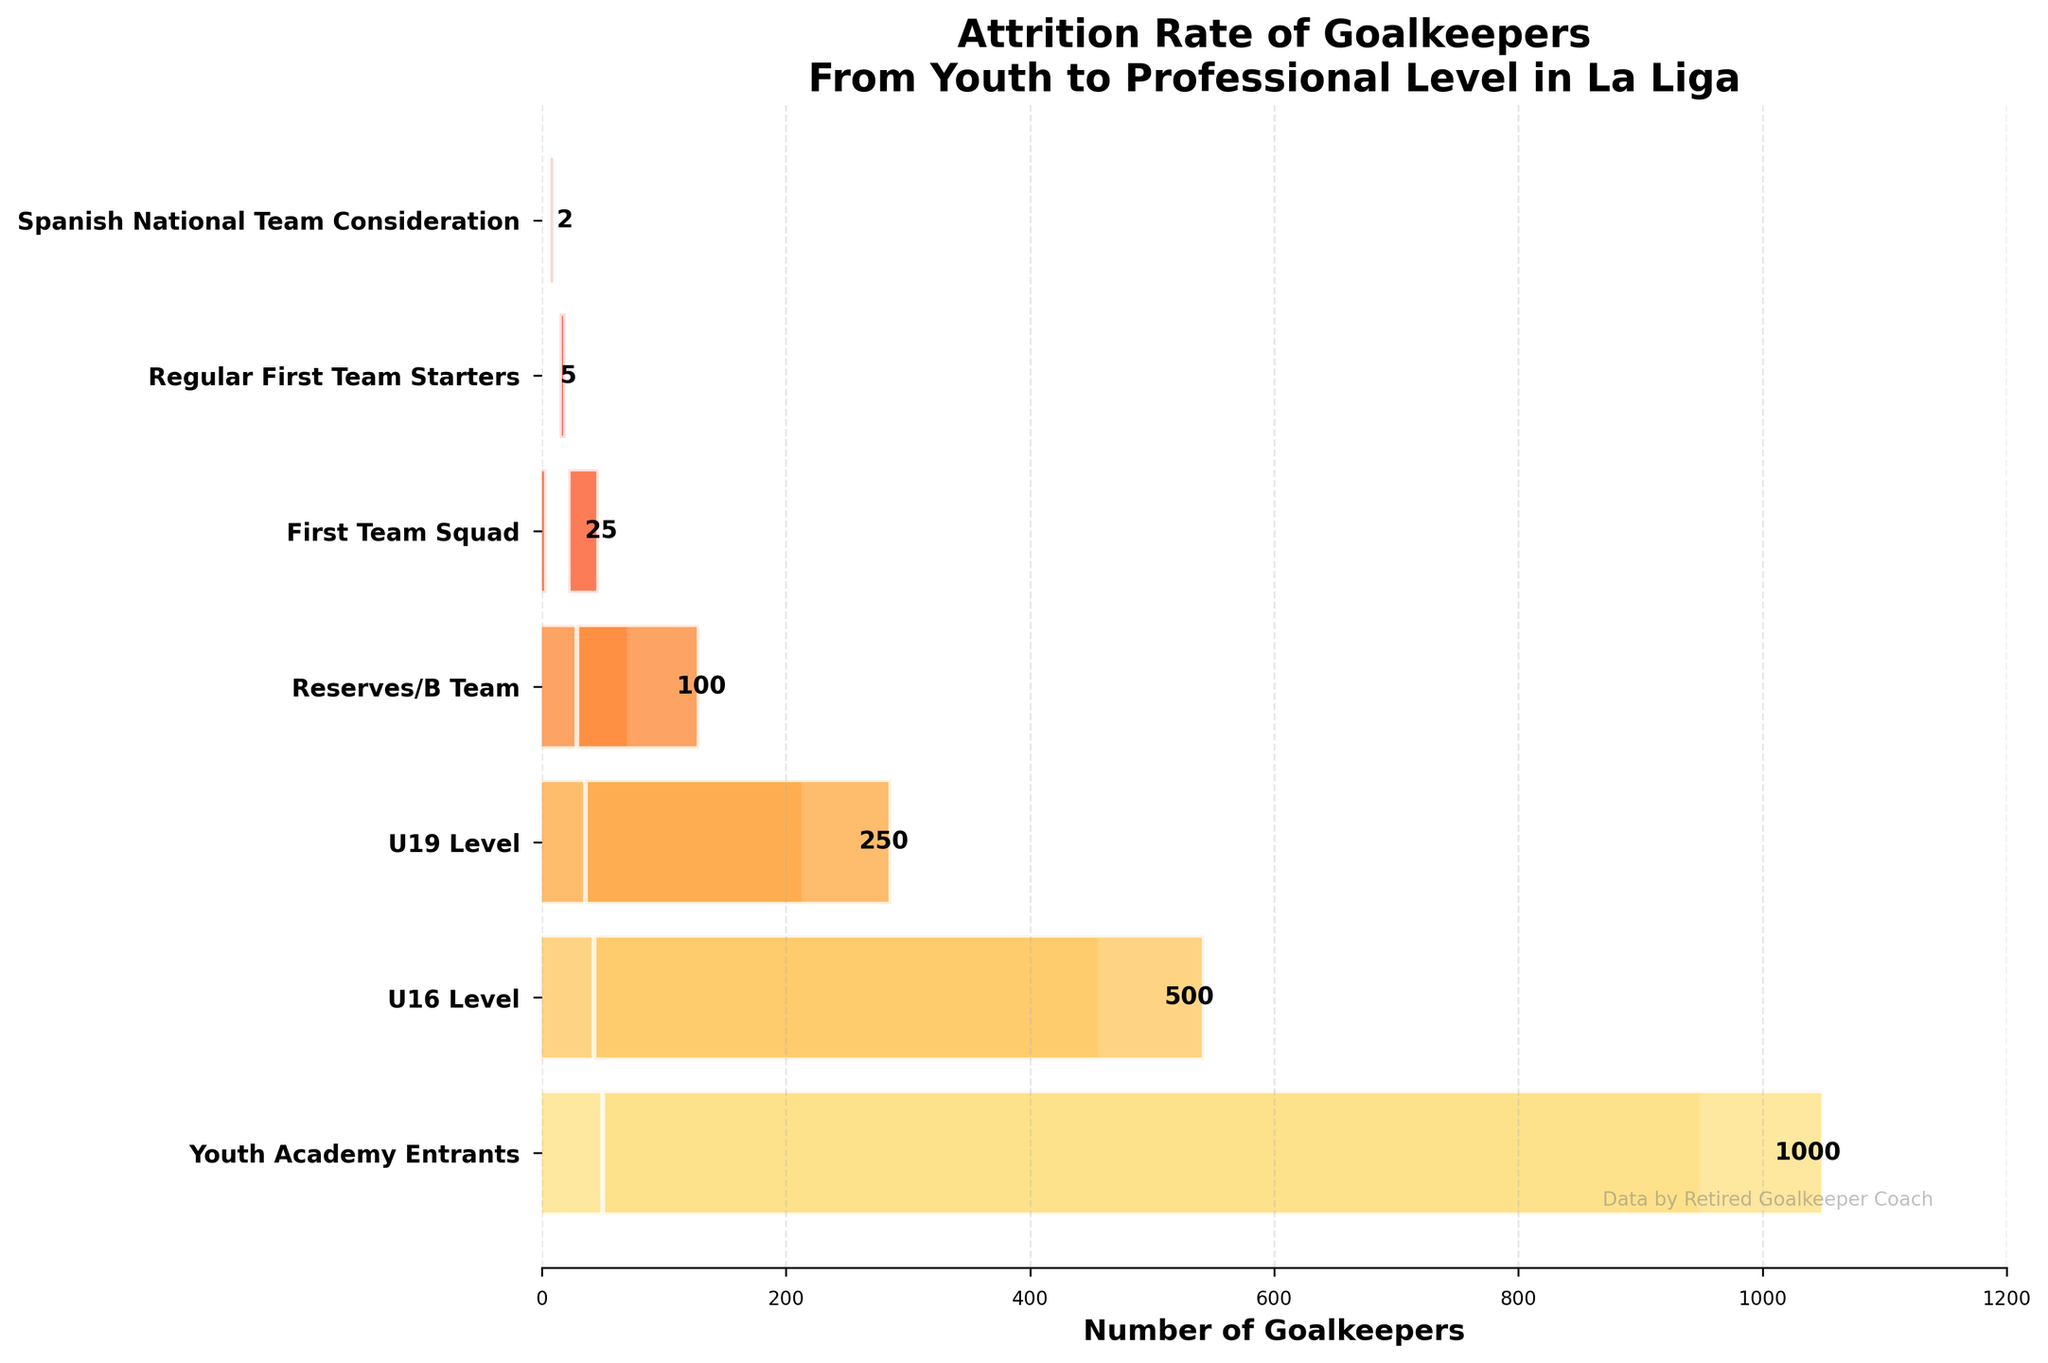Which stage has the highest number of goalkeepers? The highest point in a funnel chart often represents the starting point/stage with the largest number of participants. Here, the Youth Academy Entrants stage has the highest count.
Answer: Youth Academy Entrants What is the title of the chart? The title of a plot is usually located at the top-center of the chart. Here, it states, 'Attrition Rate of Goalkeepers From Youth to Professional Level in La Liga'.
Answer: Attrition Rate of Goalkeepers From Youth to Professional Level in La Liga Which stage has the fewest number of goalkeepers? A funnel chart narrows down to its lowest point at the stage with the fewest participants. Here, it's the Spanish National Team Consideration stage with 2 goalkeepers.
Answer: Spanish National Team Consideration How many goalkeepers make it from the U16 Level to the U19 Level? The plot shows 500 goalkeepers at the U16 Level and 250 at the U19 Level. To find the number that make it through, simply look at the numbers for these stages.
Answer: 250 How many goalkeepers drop out between the Youth Academy Entrants and the U16 Level? The difference between the number of goalkeepers at the Youth Academy Entrants (1000) and the U16 Level (500) provides the number that drop out. 1000 - 500 = 500
Answer: 500 What is the ratio of Regular First Team Starters to First Team Squad members? To find the ratio, divide the number of Regular First Team Starters (5) by the number in the First Team Squad (25). 5 / 25 = 0.2 or 1:5
Answer: 1:5 Compare the number of goalkeepers between the Reserves/B Team and the U19 Level. The Reserves/B Team has 100 goalkeepers whereas the U19 Level has 250. The U19 Level has more than twice as many goalkeepers compared to the Reserves/B Team.
Answer: U19 Level has more What percentage of the original Youth Academy Entrants reach the First Team Squad? To find this, divide the number in the First Team Squad (25) by the initial Youth Academy Entrants (1000) and multiply by 100 to get the percentage. (25 / 1000) * 100 = 2.5%
Answer: 2.5% How many goalkeepers from the First Team Squad actually become Regular First Team Starters? Looking at the funnel chart, the First Team Squad consists of 25 goalkeepers, and from these, 5 become Regular First Team Starters.
Answer: 5 What is the cumulative drop in numbers from the U19 Level to the stage of Spanish National Team Consideration? Calculate the cumulative drop by subtracting the Spanish National Team Consideration (2 goalkeepers) from the U19 Level (250 goalkeepers). 250 - 2 = 248
Answer: 248 